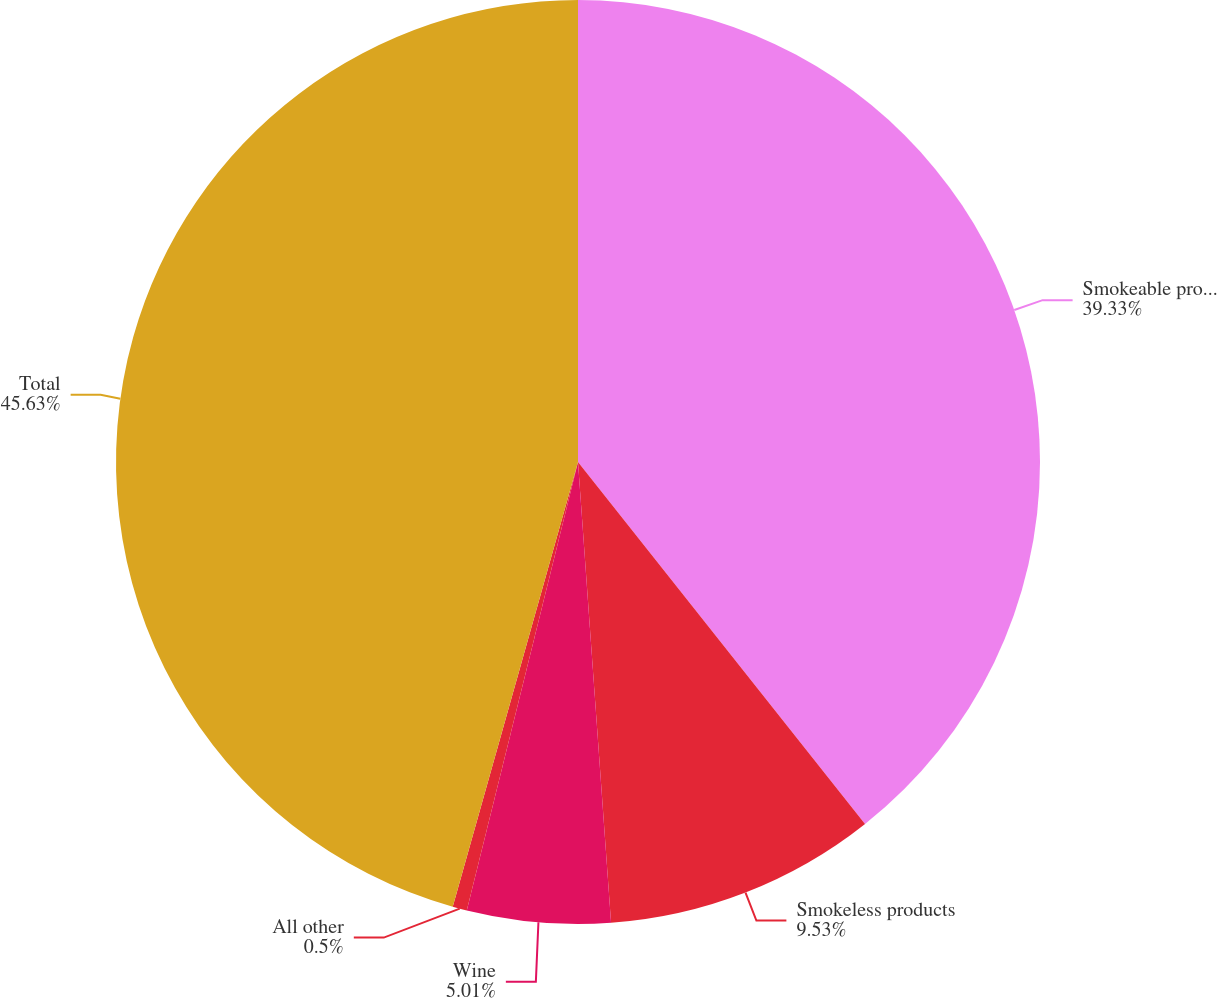Convert chart. <chart><loc_0><loc_0><loc_500><loc_500><pie_chart><fcel>Smokeable products<fcel>Smokeless products<fcel>Wine<fcel>All other<fcel>Total<nl><fcel>39.33%<fcel>9.53%<fcel>5.01%<fcel>0.5%<fcel>45.63%<nl></chart> 